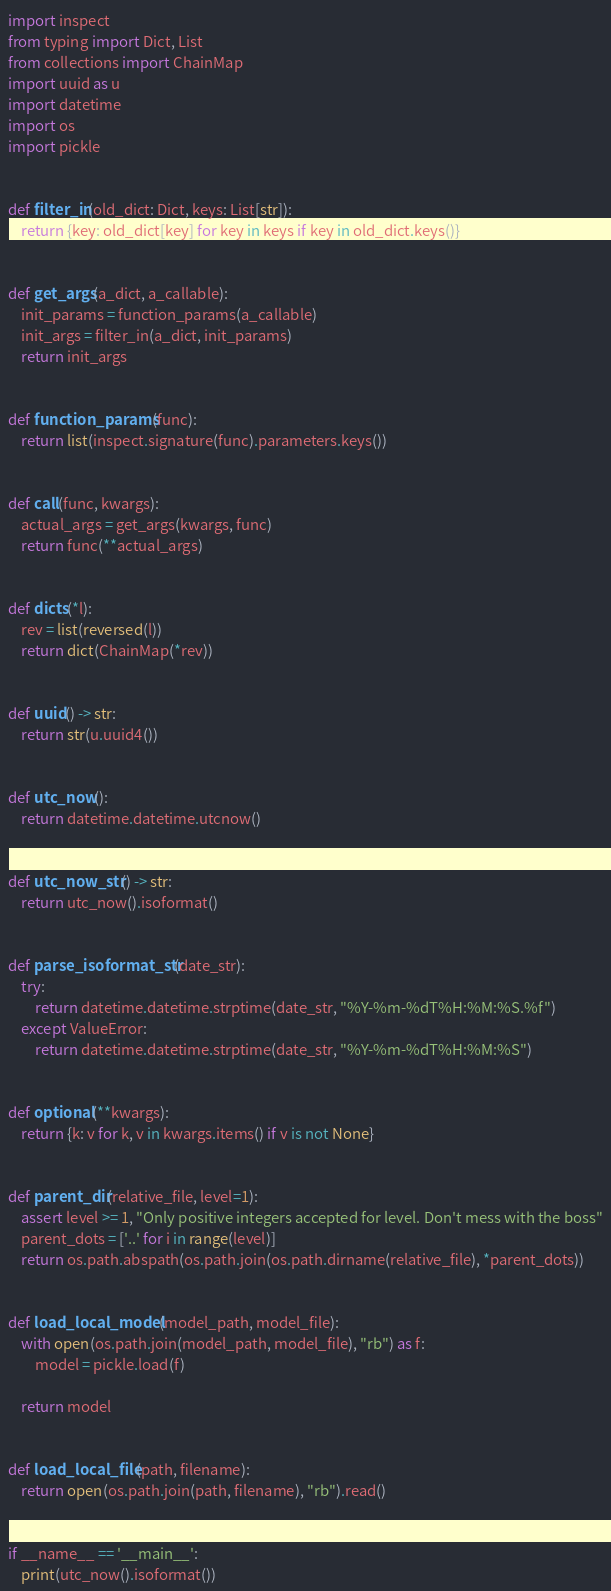<code> <loc_0><loc_0><loc_500><loc_500><_Python_>import inspect
from typing import Dict, List
from collections import ChainMap
import uuid as u
import datetime
import os
import pickle


def filter_in(old_dict: Dict, keys: List[str]):
    return {key: old_dict[key] for key in keys if key in old_dict.keys()}


def get_args(a_dict, a_callable):
    init_params = function_params(a_callable)
    init_args = filter_in(a_dict, init_params)
    return init_args


def function_params(func):
    return list(inspect.signature(func).parameters.keys())


def call(func, kwargs):
    actual_args = get_args(kwargs, func)
    return func(**actual_args)


def dicts(*l):
    rev = list(reversed(l))
    return dict(ChainMap(*rev))


def uuid() -> str:
    return str(u.uuid4())


def utc_now():
    return datetime.datetime.utcnow()


def utc_now_str() -> str:
    return utc_now().isoformat()


def parse_isoformat_str(date_str):
    try:
        return datetime.datetime.strptime(date_str, "%Y-%m-%dT%H:%M:%S.%f")
    except ValueError:
        return datetime.datetime.strptime(date_str, "%Y-%m-%dT%H:%M:%S")


def optional(**kwargs):
    return {k: v for k, v in kwargs.items() if v is not None}


def parent_dir(relative_file, level=1):
    assert level >= 1, "Only positive integers accepted for level. Don't mess with the boss"
    parent_dots = ['..' for i in range(level)]
    return os.path.abspath(os.path.join(os.path.dirname(relative_file), *parent_dots))


def load_local_model(model_path, model_file):
    with open(os.path.join(model_path, model_file), "rb") as f:
        model = pickle.load(f)

    return model


def load_local_file(path, filename):
    return open(os.path.join(path, filename), "rb").read()


if __name__ == '__main__':
    print(utc_now().isoformat())
</code> 